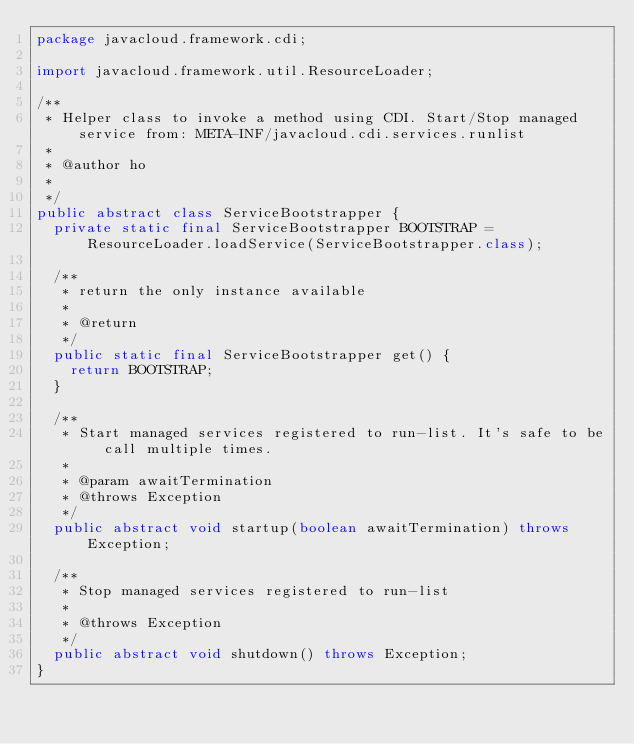<code> <loc_0><loc_0><loc_500><loc_500><_Java_>package javacloud.framework.cdi;

import javacloud.framework.util.ResourceLoader;

/**
 * Helper class to invoke a method using CDI. Start/Stop managed service from: META-INF/javacloud.cdi.services.runlist
 * 
 * @author ho
 *
 */
public abstract class ServiceBootstrapper {
	private static final ServiceBootstrapper BOOTSTRAP = ResourceLoader.loadService(ServiceBootstrapper.class);
	
	/**
	 * return the only instance available
	 * 
	 * @return
	 */
	public static final ServiceBootstrapper get() {
		return BOOTSTRAP;
	}
	
	/**
	 * Start managed services registered to run-list. It's safe to be call multiple times.
	 * 
	 * @param awaitTermination
	 * @throws Exception
	 */
	public abstract void startup(boolean awaitTermination) throws Exception;
	
	/**
	 * Stop managed services registered to run-list
	 * 
	 * @throws Exception
	 */
	public abstract void shutdown() throws Exception;
}
</code> 